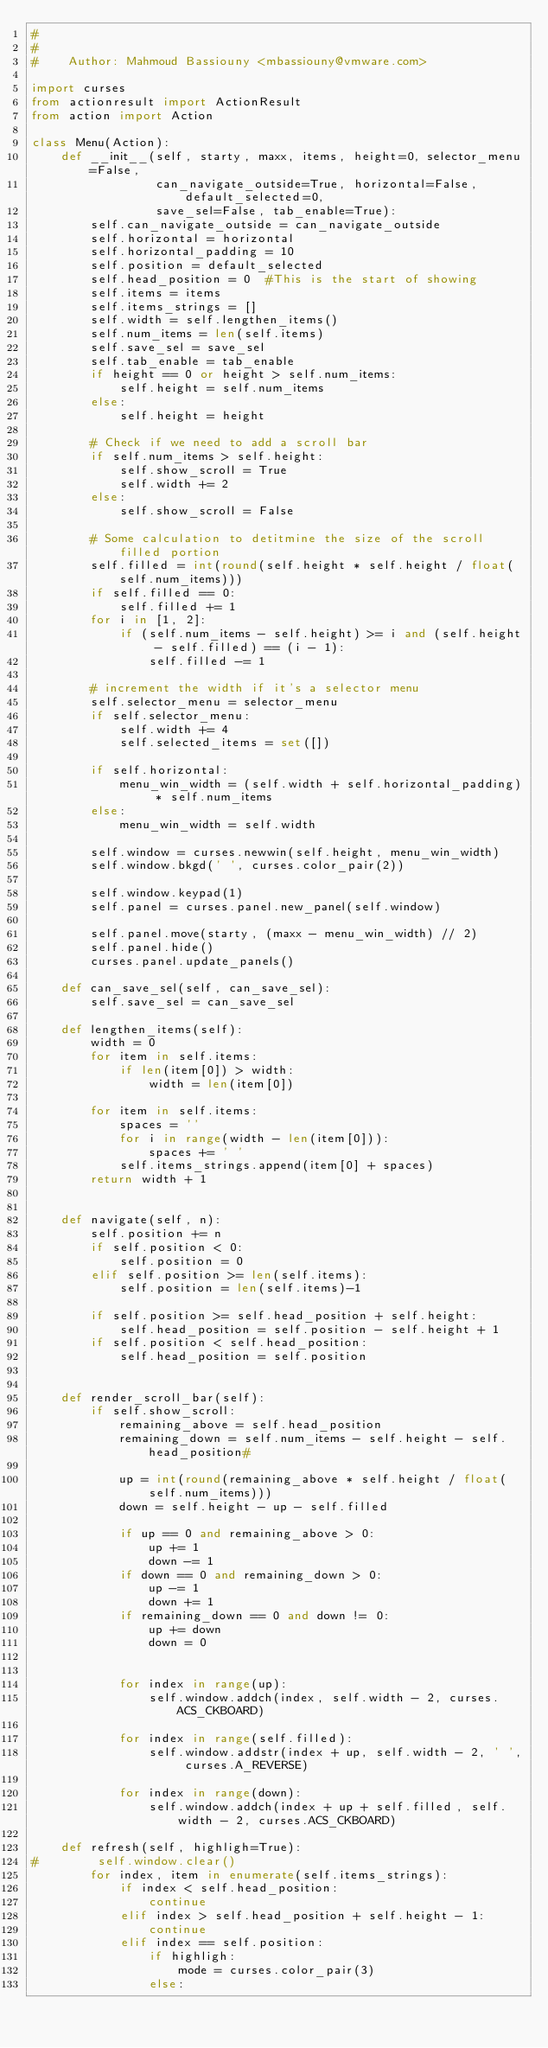<code> <loc_0><loc_0><loc_500><loc_500><_Python_>#
#
#    Author: Mahmoud Bassiouny <mbassiouny@vmware.com>

import curses
from actionresult import ActionResult
from action import Action

class Menu(Action):
    def __init__(self, starty, maxx, items, height=0, selector_menu=False,
                 can_navigate_outside=True, horizontal=False, default_selected=0,
                 save_sel=False, tab_enable=True):
        self.can_navigate_outside = can_navigate_outside
        self.horizontal = horizontal
        self.horizontal_padding = 10
        self.position = default_selected
        self.head_position = 0  #This is the start of showing
        self.items = items
        self.items_strings = []
        self.width = self.lengthen_items()
        self.num_items = len(self.items)
        self.save_sel = save_sel
        self.tab_enable = tab_enable
        if height == 0 or height > self.num_items:
            self.height = self.num_items
        else:
            self.height = height

        # Check if we need to add a scroll bar
        if self.num_items > self.height:
            self.show_scroll = True
            self.width += 2
        else:
            self.show_scroll = False

        # Some calculation to detitmine the size of the scroll filled portion
        self.filled = int(round(self.height * self.height / float(self.num_items)))
        if self.filled == 0:
            self.filled += 1
        for i in [1, 2]:
            if (self.num_items - self.height) >= i and (self.height - self.filled) == (i - 1):
                self.filled -= 1

        # increment the width if it's a selector menu
        self.selector_menu = selector_menu
        if self.selector_menu:
            self.width += 4
            self.selected_items = set([])

        if self.horizontal:
            menu_win_width = (self.width + self.horizontal_padding) * self.num_items
        else:
            menu_win_width = self.width

        self.window = curses.newwin(self.height, menu_win_width)
        self.window.bkgd(' ', curses.color_pair(2))

        self.window.keypad(1)
        self.panel = curses.panel.new_panel(self.window)

        self.panel.move(starty, (maxx - menu_win_width) // 2)
        self.panel.hide()
        curses.panel.update_panels()

    def can_save_sel(self, can_save_sel):
        self.save_sel = can_save_sel

    def lengthen_items(self):
        width = 0
        for item in self.items:
            if len(item[0]) > width:
                width = len(item[0])

        for item in self.items:
            spaces = ''
            for i in range(width - len(item[0])):
                spaces += ' '
            self.items_strings.append(item[0] + spaces)
        return width + 1


    def navigate(self, n):
        self.position += n
        if self.position < 0:
            self.position = 0
        elif self.position >= len(self.items):
            self.position = len(self.items)-1

        if self.position >= self.head_position + self.height:
            self.head_position = self.position - self.height + 1
        if self.position < self.head_position:
            self.head_position = self.position


    def render_scroll_bar(self):
        if self.show_scroll:
            remaining_above = self.head_position
            remaining_down = self.num_items - self.height - self.head_position#

            up = int(round(remaining_above * self.height / float(self.num_items)))
            down = self.height - up - self.filled

            if up == 0 and remaining_above > 0:
                up += 1
                down -= 1
            if down == 0 and remaining_down > 0:
                up -= 1
                down += 1
            if remaining_down == 0 and down != 0:
                up += down
                down = 0


            for index in range(up):
                self.window.addch(index, self.width - 2, curses.ACS_CKBOARD)

            for index in range(self.filled):
                self.window.addstr(index + up, self.width - 2, ' ', curses.A_REVERSE)

            for index in range(down):
                self.window.addch(index + up + self.filled, self.width - 2, curses.ACS_CKBOARD)

    def refresh(self, highligh=True):
#        self.window.clear()
        for index, item in enumerate(self.items_strings):
            if index < self.head_position:
                continue
            elif index > self.head_position + self.height - 1:
                continue
            elif index == self.position:
                if highligh:
                    mode = curses.color_pair(3)
                else:</code> 